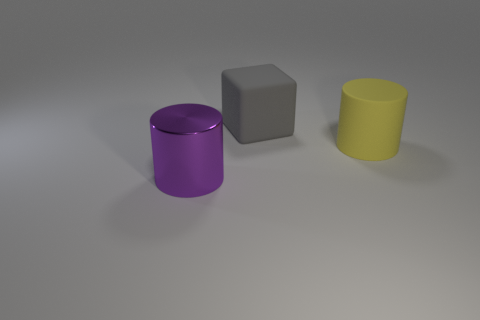Add 1 purple metal cylinders. How many objects exist? 4 Subtract all cylinders. How many objects are left? 1 Add 3 big red shiny cylinders. How many big red shiny cylinders exist? 3 Subtract 0 gray cylinders. How many objects are left? 3 Subtract all large yellow cylinders. Subtract all big purple metal cylinders. How many objects are left? 1 Add 2 big cubes. How many big cubes are left? 3 